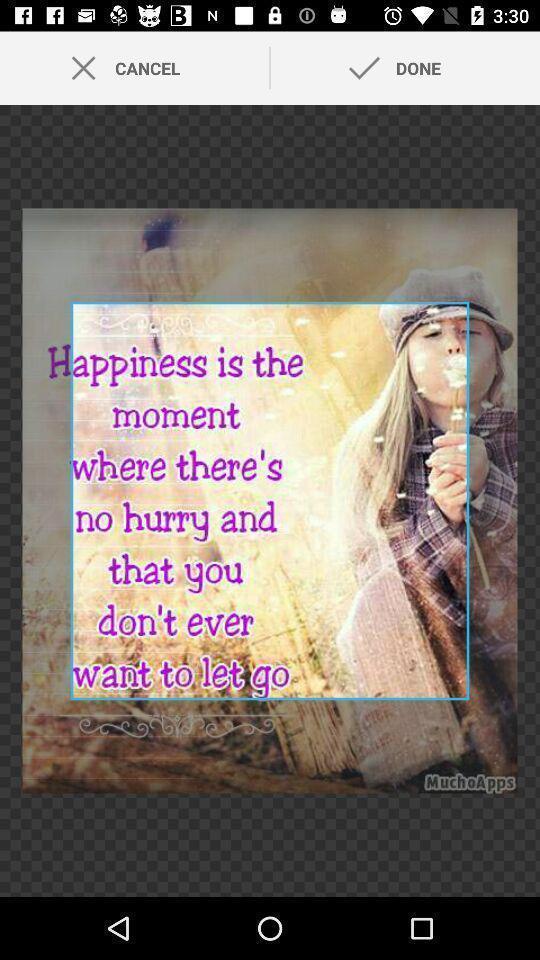Describe this image in words. Screen displaying control options for a photo editing application. 